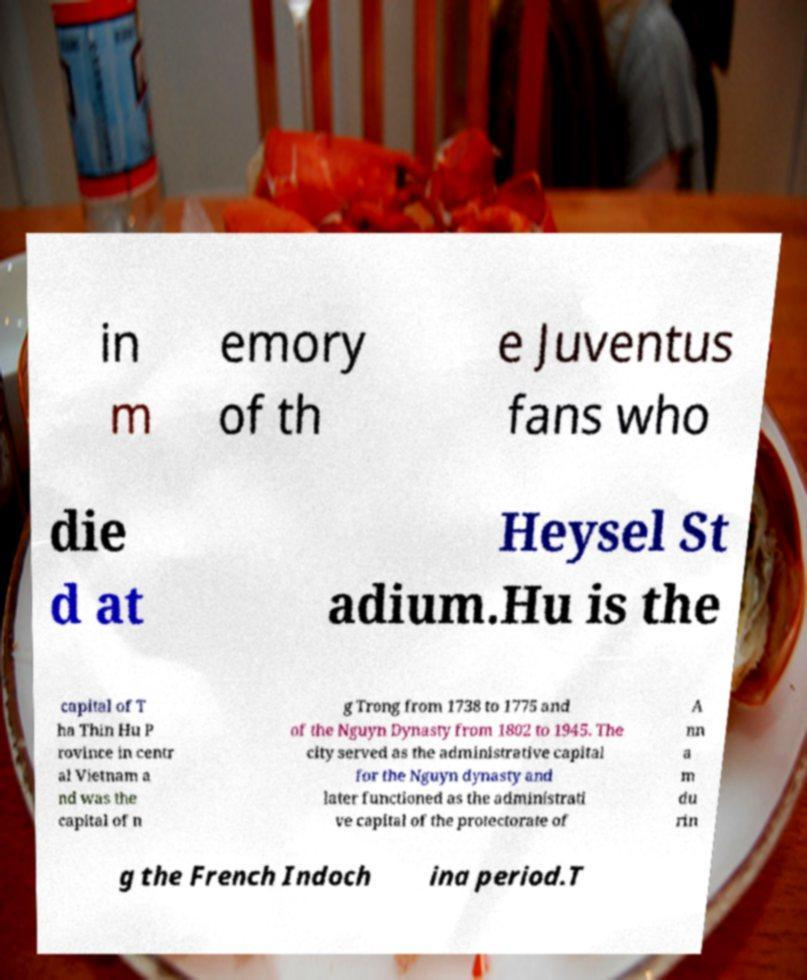For documentation purposes, I need the text within this image transcribed. Could you provide that? in m emory of th e Juventus fans who die d at Heysel St adium.Hu is the capital of T ha Thin Hu P rovince in centr al Vietnam a nd was the capital of n g Trong from 1738 to 1775 and of the Nguyn Dynasty from 1802 to 1945. The city served as the administrative capital for the Nguyn dynasty and later functioned as the administrati ve capital of the protectorate of A nn a m du rin g the French Indoch ina period.T 